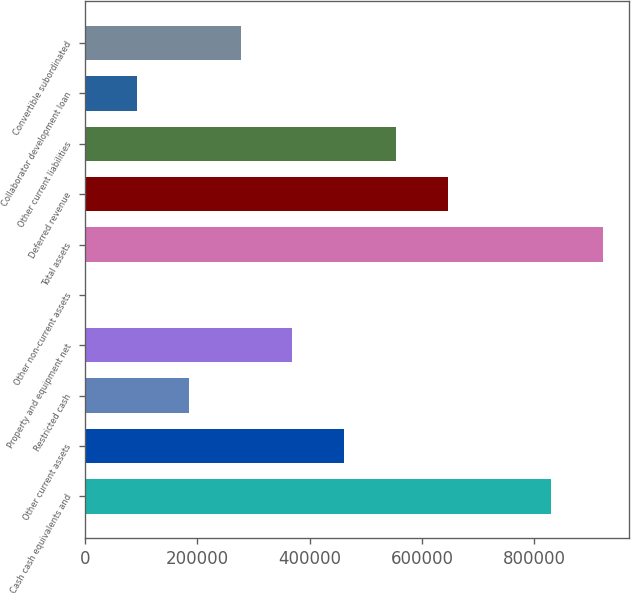<chart> <loc_0><loc_0><loc_500><loc_500><bar_chart><fcel>Cash cash equivalents and<fcel>Other current assets<fcel>Restricted cash<fcel>Property and equipment net<fcel>Other non-current assets<fcel>Total assets<fcel>Deferred revenue<fcel>Other current liabilities<fcel>Collaborator development loan<fcel>Convertible subordinated<nl><fcel>829546<fcel>461416<fcel>185319<fcel>369384<fcel>1254<fcel>921579<fcel>645482<fcel>553449<fcel>93286.5<fcel>277352<nl></chart> 